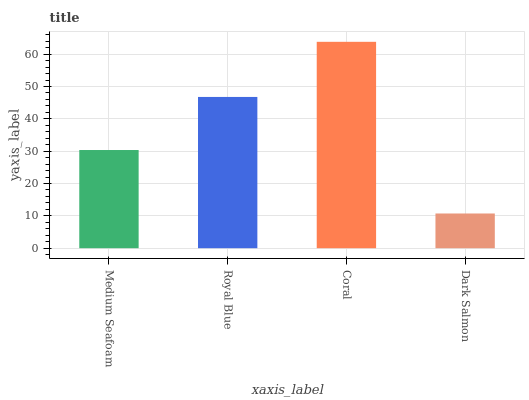Is Dark Salmon the minimum?
Answer yes or no. Yes. Is Coral the maximum?
Answer yes or no. Yes. Is Royal Blue the minimum?
Answer yes or no. No. Is Royal Blue the maximum?
Answer yes or no. No. Is Royal Blue greater than Medium Seafoam?
Answer yes or no. Yes. Is Medium Seafoam less than Royal Blue?
Answer yes or no. Yes. Is Medium Seafoam greater than Royal Blue?
Answer yes or no. No. Is Royal Blue less than Medium Seafoam?
Answer yes or no. No. Is Royal Blue the high median?
Answer yes or no. Yes. Is Medium Seafoam the low median?
Answer yes or no. Yes. Is Dark Salmon the high median?
Answer yes or no. No. Is Coral the low median?
Answer yes or no. No. 